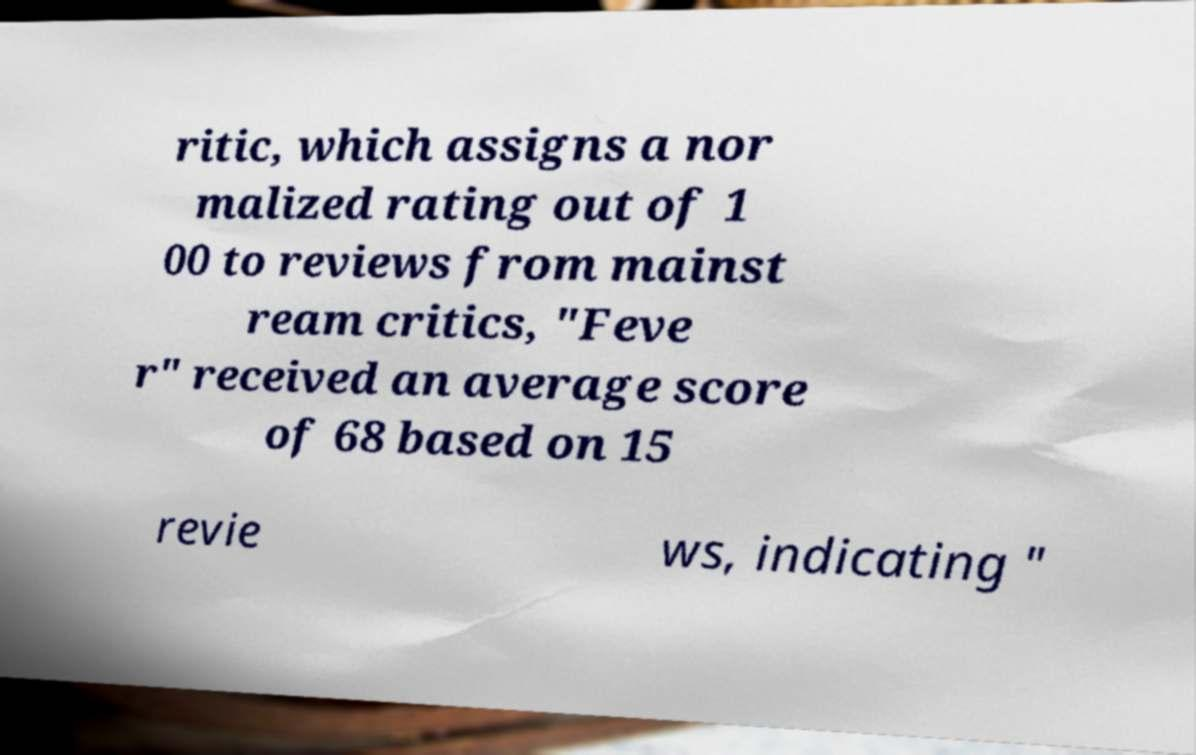What messages or text are displayed in this image? I need them in a readable, typed format. ritic, which assigns a nor malized rating out of 1 00 to reviews from mainst ream critics, "Feve r" received an average score of 68 based on 15 revie ws, indicating " 